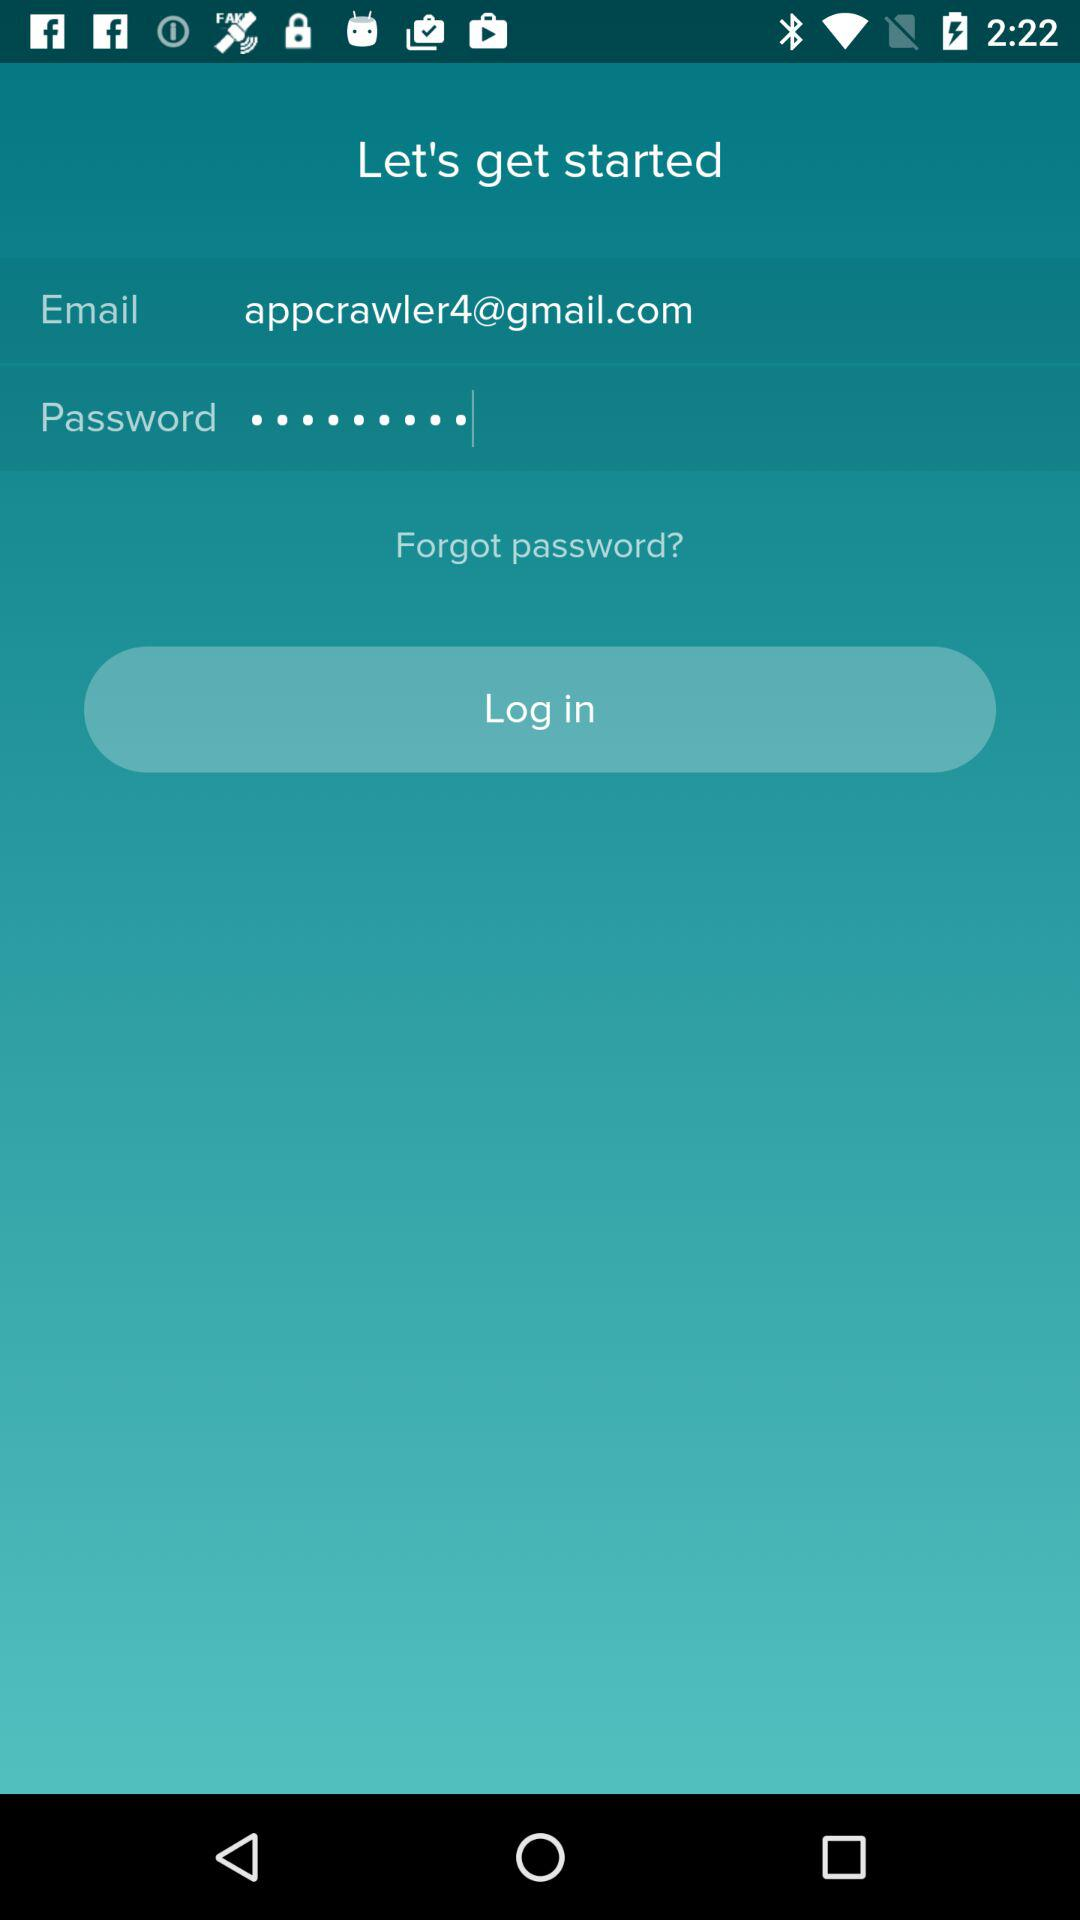What is the email address? The email address is appcrawler4@gmail.com. 